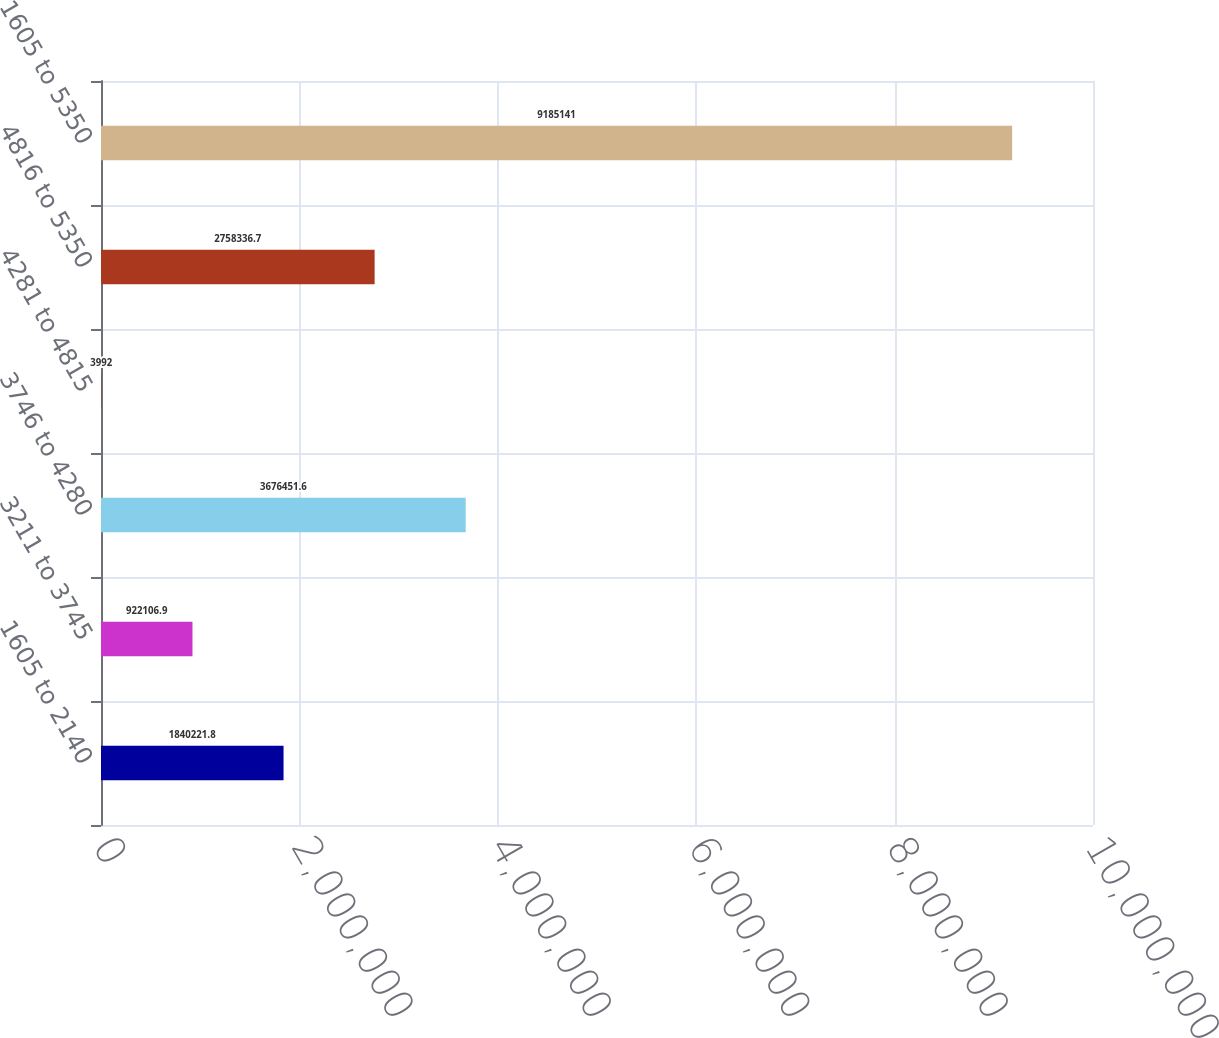Convert chart. <chart><loc_0><loc_0><loc_500><loc_500><bar_chart><fcel>1605 to 2140<fcel>3211 to 3745<fcel>3746 to 4280<fcel>4281 to 4815<fcel>4816 to 5350<fcel>1605 to 5350<nl><fcel>1.84022e+06<fcel>922107<fcel>3.67645e+06<fcel>3992<fcel>2.75834e+06<fcel>9.18514e+06<nl></chart> 